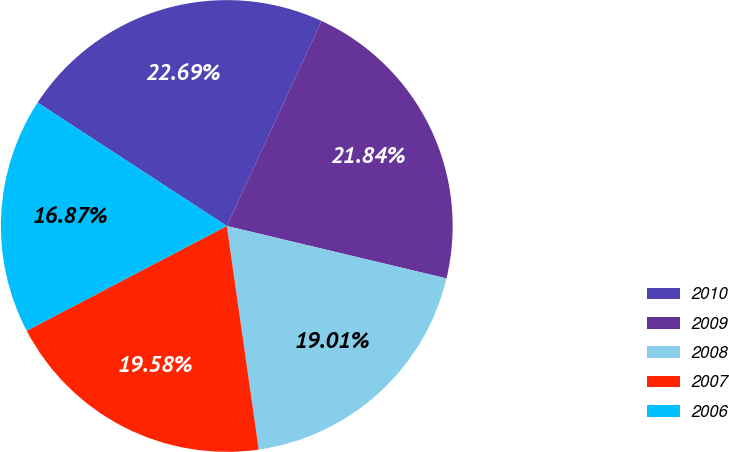Convert chart. <chart><loc_0><loc_0><loc_500><loc_500><pie_chart><fcel>2010<fcel>2009<fcel>2008<fcel>2007<fcel>2006<nl><fcel>22.69%<fcel>21.84%<fcel>19.01%<fcel>19.58%<fcel>16.87%<nl></chart> 